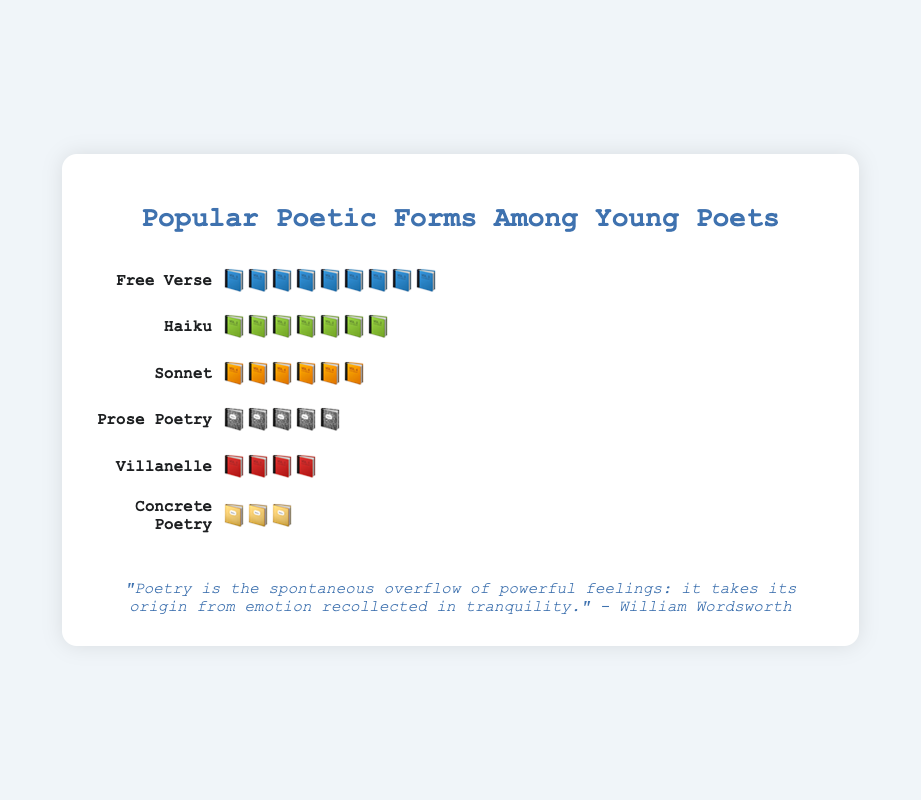Which poetic form is the most popular among young poets? The figure shows "Free Verse" with the most number of book emojis.
Answer: Free Verse How many book emojis represent the popularity of Haiku? The Haiku category in the figure has 7 book emojis.
Answer: 7 Which poetic form has the least popularity? The figure indicates that "Concrete Poetry" has the least number of book emojis.
Answer: Concrete Poetry What's the difference in popularity between Sonnet and Prose Poetry? Sonnet has 6 book emojis while Prose Poetry has 5, so the difference is 6 - 5 = 1.
Answer: 1 Which two poetic forms have consecutive emoji counts differing by one? Prose Poetry has 5 emojis and Villanelle has 4, making their counts differ by 1.
Answer: Prose Poetry and Villanelle If you sum up the emojis for Haiku and Villanelle, how many do you get? Haiku has 7 emojis and Villanelle has 4, summing up to 7 + 4 = 11.
Answer: 11 What is the average popularity (in terms of emojis) of all the poetic forms listed? Sum all the emojis (9+7+6+5+4+3=34) and divide by the number of forms (6) to get the average 34/6 ≈ 5.67.
Answer: 5.67 Does Free Verse have more than twice as many emojis as Concrete Poetry? Free Verse has 9 emojis and Concrete Poetry has 3; 9 is indeed more than 2 * 3 = 6.
Answer: Yes Which poetic form has popularity just below Free Verse? The poetic form with popularity just below Free Verse (9) is Haiku with 7 emojis.
Answer: Haiku 